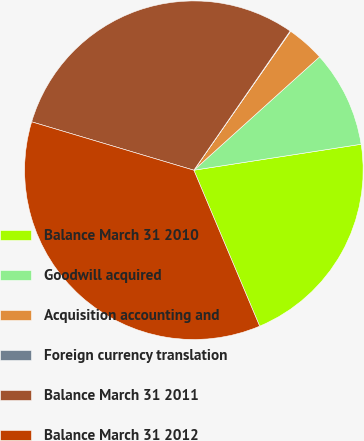Convert chart to OTSL. <chart><loc_0><loc_0><loc_500><loc_500><pie_chart><fcel>Balance March 31 2010<fcel>Goodwill acquired<fcel>Acquisition accounting and<fcel>Foreign currency translation<fcel>Balance March 31 2011<fcel>Balance March 31 2012<nl><fcel>21.1%<fcel>9.23%<fcel>3.64%<fcel>0.05%<fcel>30.02%<fcel>35.97%<nl></chart> 